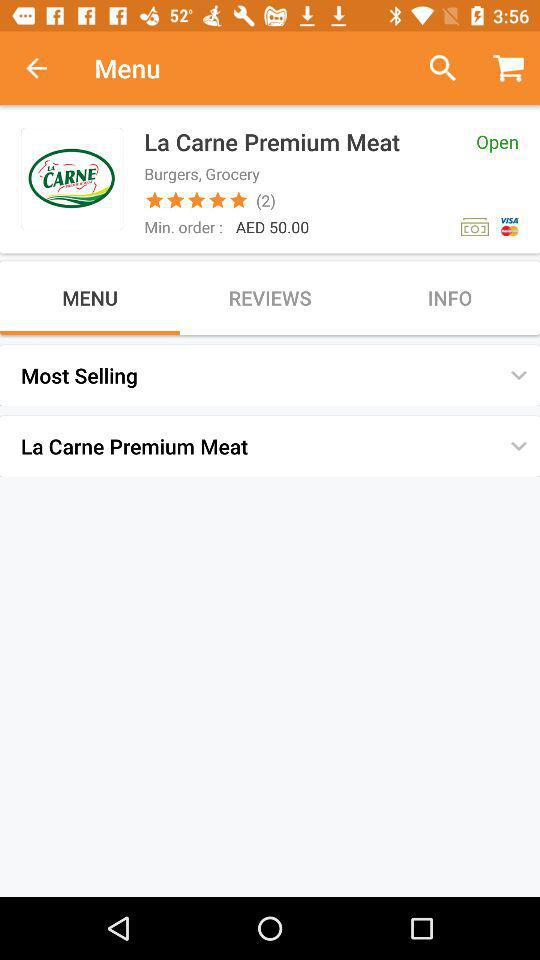What is the minimum order amount?
Answer the question using a single word or phrase. AED 50.00 